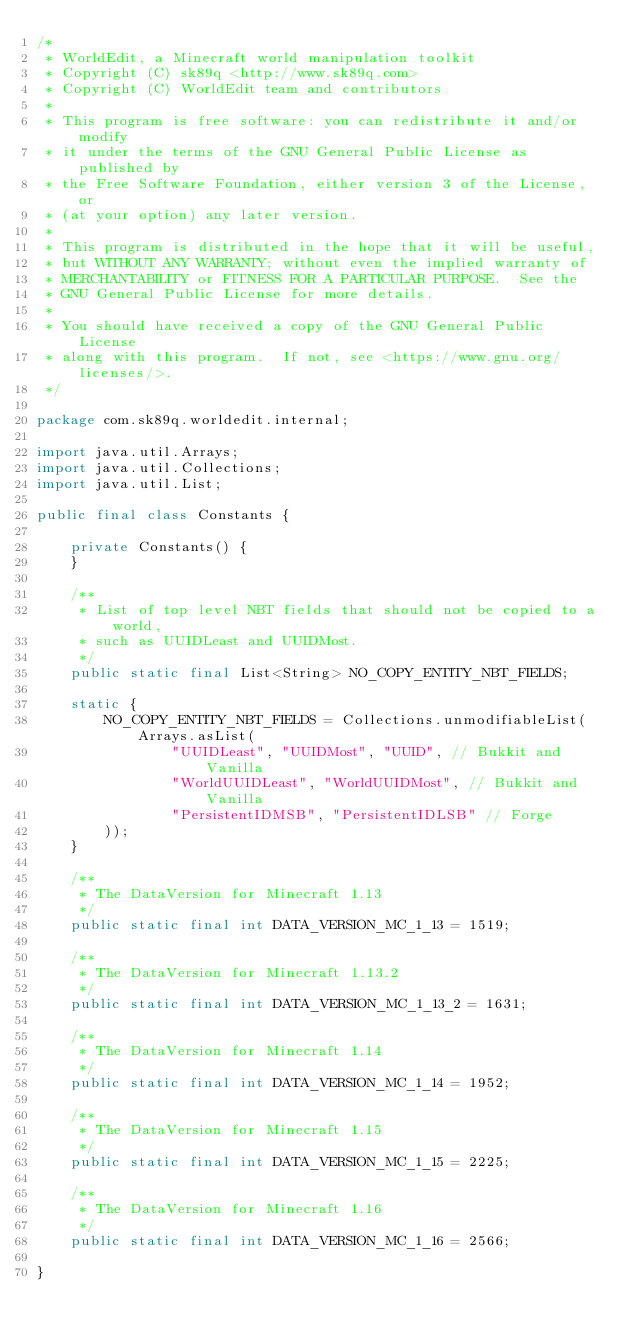<code> <loc_0><loc_0><loc_500><loc_500><_Java_>/*
 * WorldEdit, a Minecraft world manipulation toolkit
 * Copyright (C) sk89q <http://www.sk89q.com>
 * Copyright (C) WorldEdit team and contributors
 *
 * This program is free software: you can redistribute it and/or modify
 * it under the terms of the GNU General Public License as published by
 * the Free Software Foundation, either version 3 of the License, or
 * (at your option) any later version.
 *
 * This program is distributed in the hope that it will be useful,
 * but WITHOUT ANY WARRANTY; without even the implied warranty of
 * MERCHANTABILITY or FITNESS FOR A PARTICULAR PURPOSE.  See the
 * GNU General Public License for more details.
 *
 * You should have received a copy of the GNU General Public License
 * along with this program.  If not, see <https://www.gnu.org/licenses/>.
 */

package com.sk89q.worldedit.internal;

import java.util.Arrays;
import java.util.Collections;
import java.util.List;

public final class Constants {

    private Constants() {
    }

    /**
     * List of top level NBT fields that should not be copied to a world,
     * such as UUIDLeast and UUIDMost.
     */
    public static final List<String> NO_COPY_ENTITY_NBT_FIELDS;

    static {
        NO_COPY_ENTITY_NBT_FIELDS = Collections.unmodifiableList(Arrays.asList(
                "UUIDLeast", "UUIDMost", "UUID", // Bukkit and Vanilla
                "WorldUUIDLeast", "WorldUUIDMost", // Bukkit and Vanilla
                "PersistentIDMSB", "PersistentIDLSB" // Forge
        ));
    }

    /**
     * The DataVersion for Minecraft 1.13
     */
    public static final int DATA_VERSION_MC_1_13 = 1519;

    /**
     * The DataVersion for Minecraft 1.13.2
     */
    public static final int DATA_VERSION_MC_1_13_2 = 1631;

    /**
     * The DataVersion for Minecraft 1.14
     */
    public static final int DATA_VERSION_MC_1_14 = 1952;

    /**
     * The DataVersion for Minecraft 1.15
     */
    public static final int DATA_VERSION_MC_1_15 = 2225;

    /**
     * The DataVersion for Minecraft 1.16
     */
    public static final int DATA_VERSION_MC_1_16 = 2566;

}
</code> 